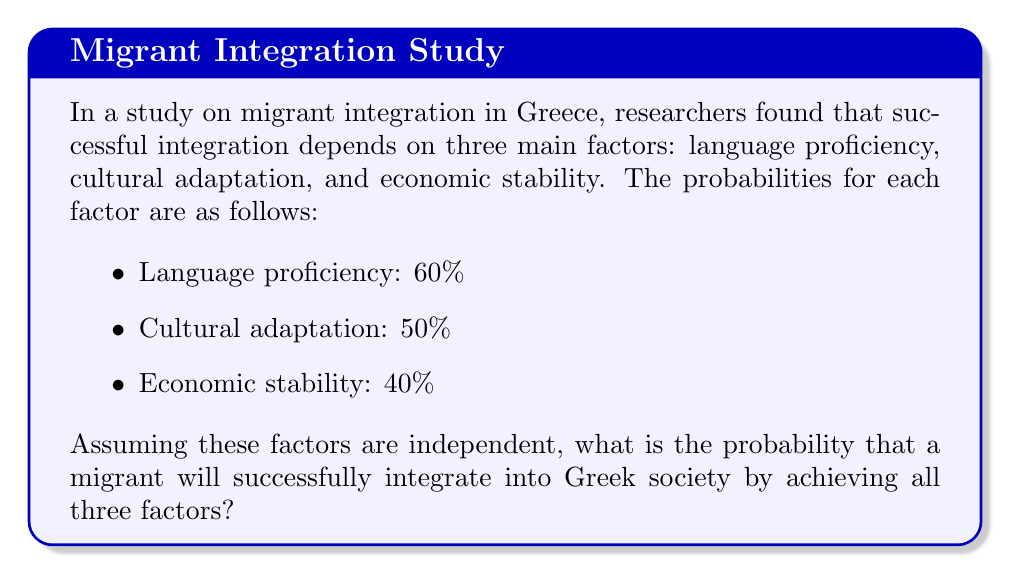Give your solution to this math problem. To solve this problem, we need to follow these steps:

1. Identify the given probabilities:
   - P(Language proficiency) = 0.60
   - P(Cultural adaptation) = 0.50
   - P(Economic stability) = 0.40

2. Since we need all three factors to occur for successful integration, and they are independent events, we multiply their individual probabilities:

   $$P(\text{Successful Integration}) = P(\text{Language}) \times P(\text{Culture}) \times P(\text{Economy})$$

3. Substitute the values:

   $$P(\text{Successful Integration}) = 0.60 \times 0.50 \times 0.40$$

4. Calculate the result:

   $$P(\text{Successful Integration}) = 0.12$$

5. Convert to a percentage:

   $$0.12 \times 100\% = 12\%$$

Therefore, the probability of a migrant successfully integrating into Greek society by achieving all three factors is 12%.
Answer: 12% 